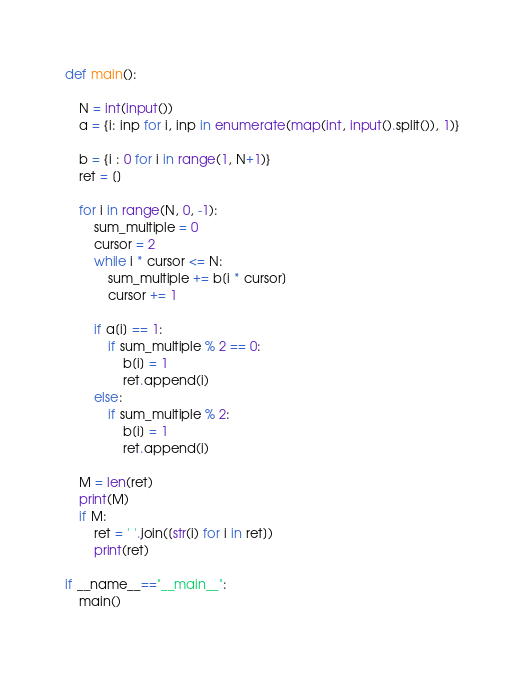Convert code to text. <code><loc_0><loc_0><loc_500><loc_500><_Python_>def main():

    N = int(input())
    a = {i: inp for i, inp in enumerate(map(int, input().split()), 1)}
        
    b = {i : 0 for i in range(1, N+1)}
    ret = []

    for i in range(N, 0, -1):
        sum_multiple = 0
        cursor = 2
        while i * cursor <= N:
            sum_multiple += b[i * cursor]
            cursor += 1

        if a[i] == 1:
            if sum_multiple % 2 == 0:
                b[i] = 1
                ret.append(i)
        else:
            if sum_multiple % 2:
                b[i] = 1
                ret.append(i)

    M = len(ret)
    print(M)
    if M:
        ret = ' '.join([str(i) for i in ret])
        print(ret)

if __name__=="__main__":
    main()</code> 